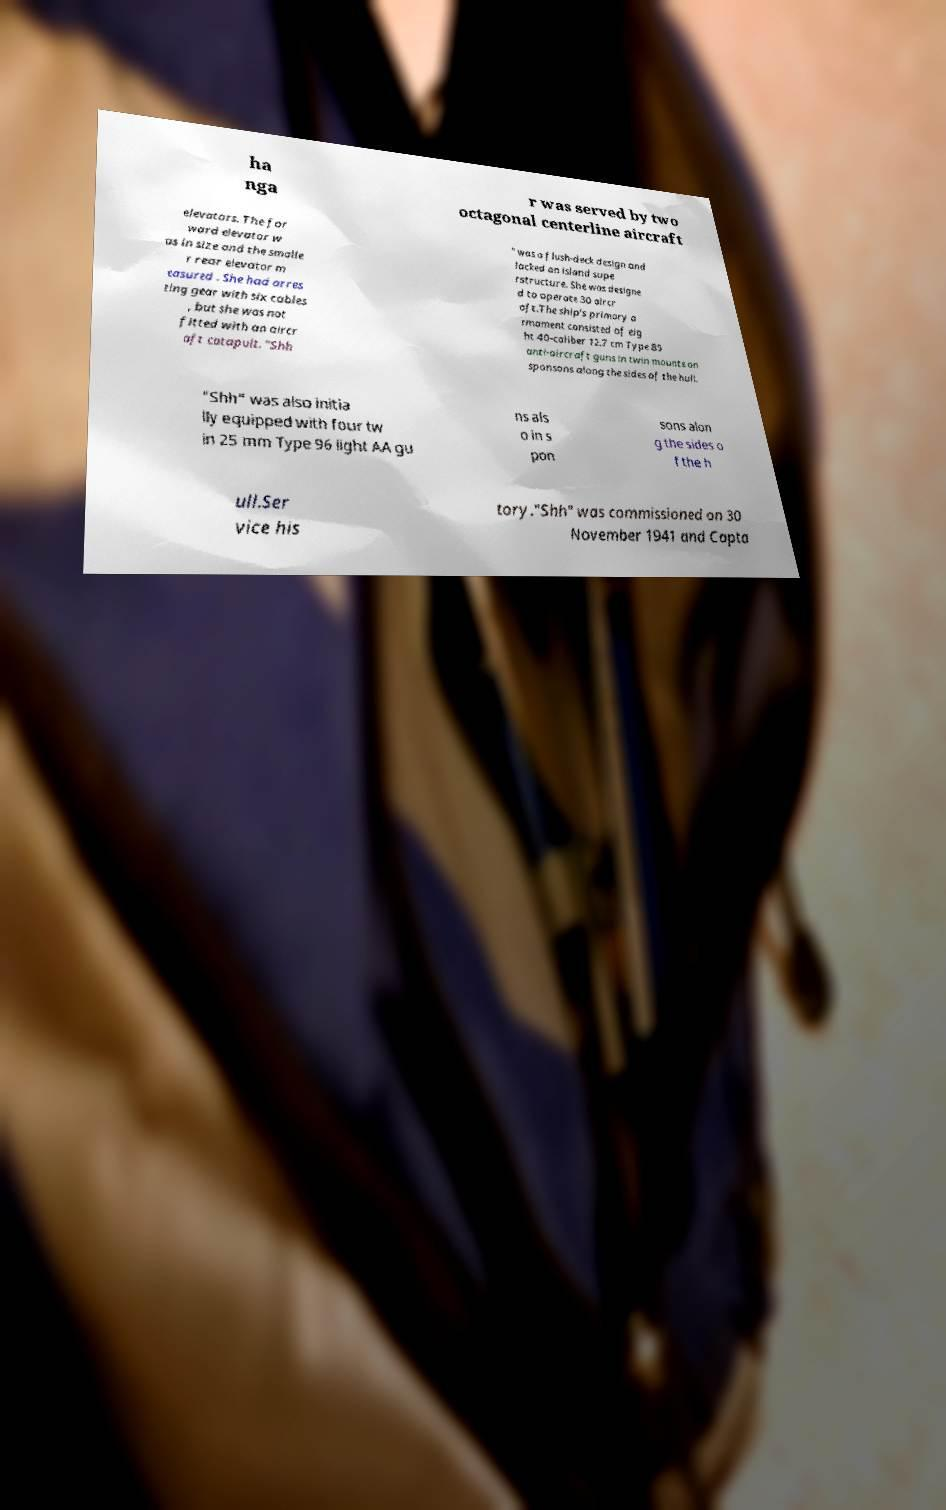Could you extract and type out the text from this image? ha nga r was served by two octagonal centerline aircraft elevators. The for ward elevator w as in size and the smalle r rear elevator m easured . She had arres ting gear with six cables , but she was not fitted with an aircr aft catapult. "Shh " was a flush-deck design and lacked an island supe rstructure. She was designe d to operate 30 aircr aft.The ship's primary a rmament consisted of eig ht 40-caliber 12.7 cm Type 89 anti-aircraft guns in twin mounts on sponsons along the sides of the hull. "Shh" was also initia lly equipped with four tw in 25 mm Type 96 light AA gu ns als o in s pon sons alon g the sides o f the h ull.Ser vice his tory."Shh" was commissioned on 30 November 1941 and Capta 